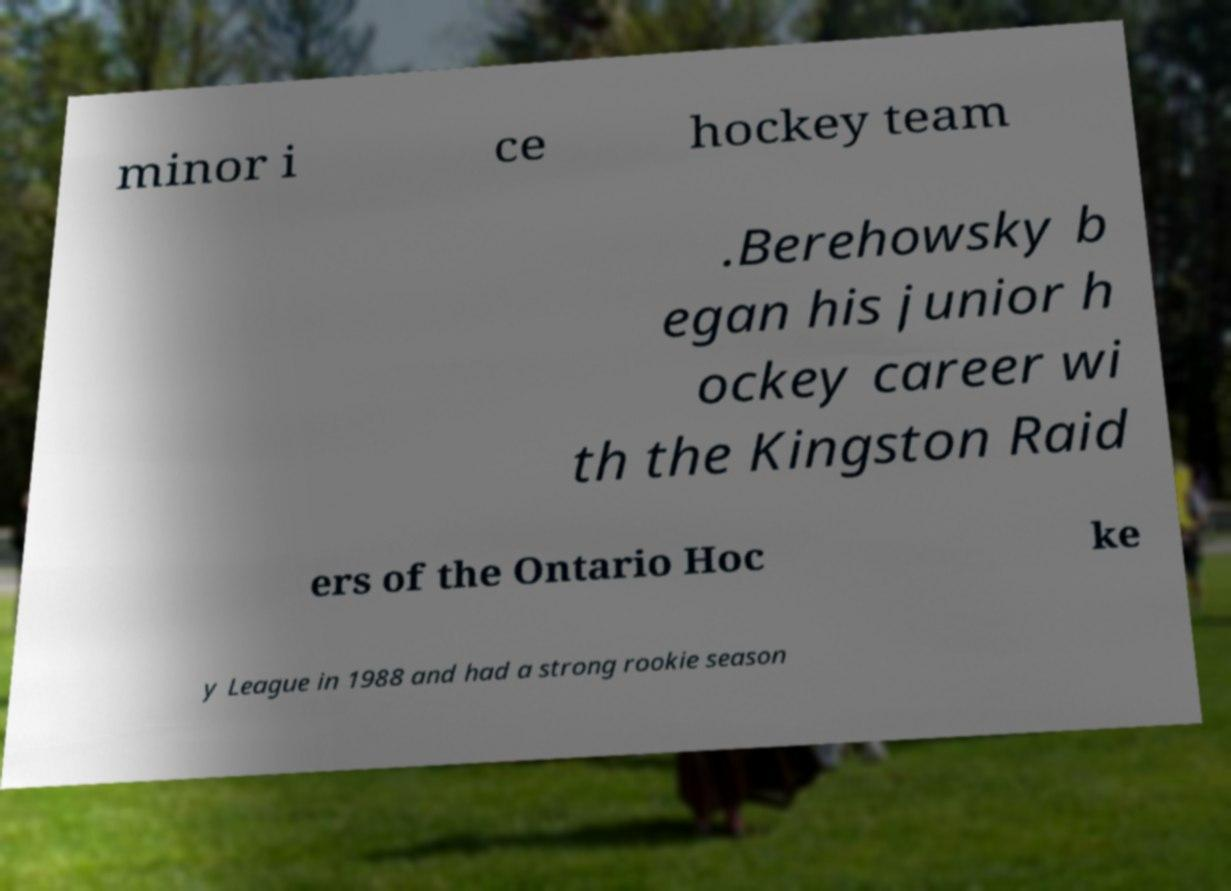Could you extract and type out the text from this image? minor i ce hockey team .Berehowsky b egan his junior h ockey career wi th the Kingston Raid ers of the Ontario Hoc ke y League in 1988 and had a strong rookie season 